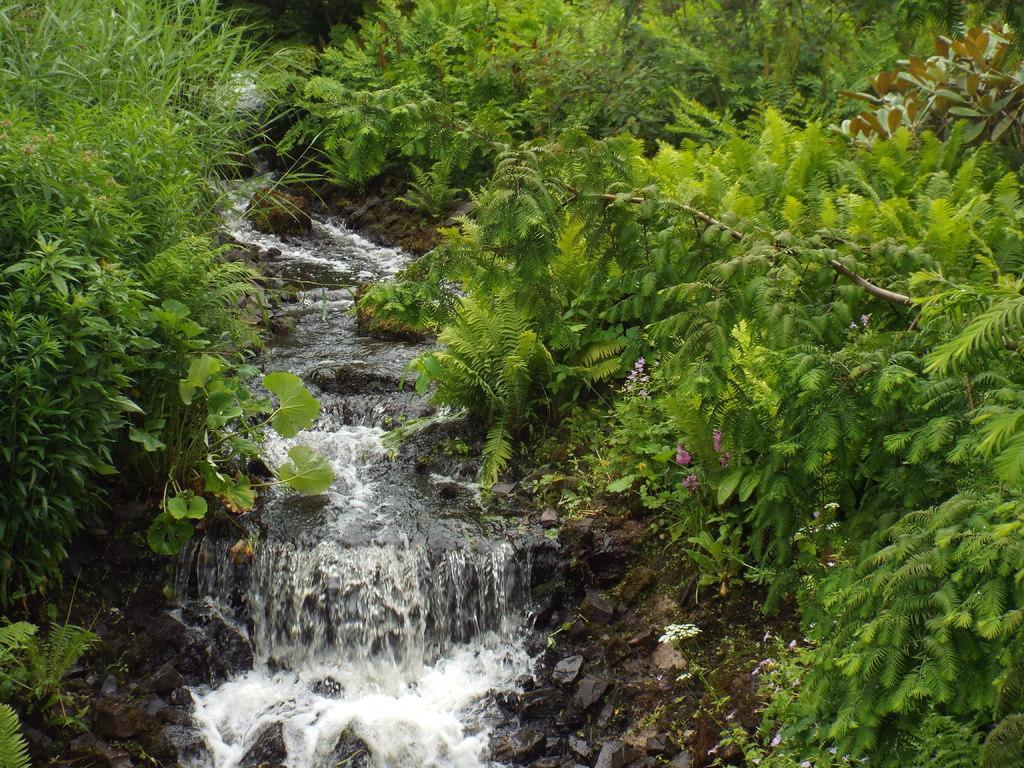In one or two sentences, can you explain what this image depicts? We can see water,green trees and flowers. 